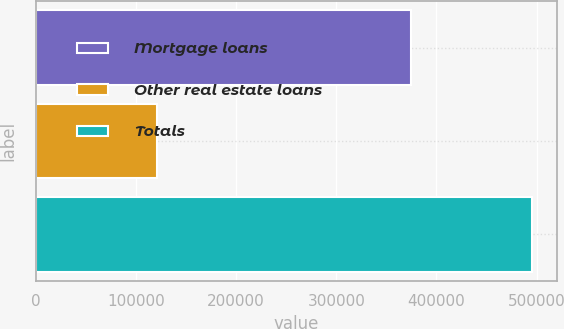Convert chart. <chart><loc_0><loc_0><loc_500><loc_500><bar_chart><fcel>Mortgage loans<fcel>Other real estate loans<fcel>Totals<nl><fcel>374492<fcel>121379<fcel>495871<nl></chart> 